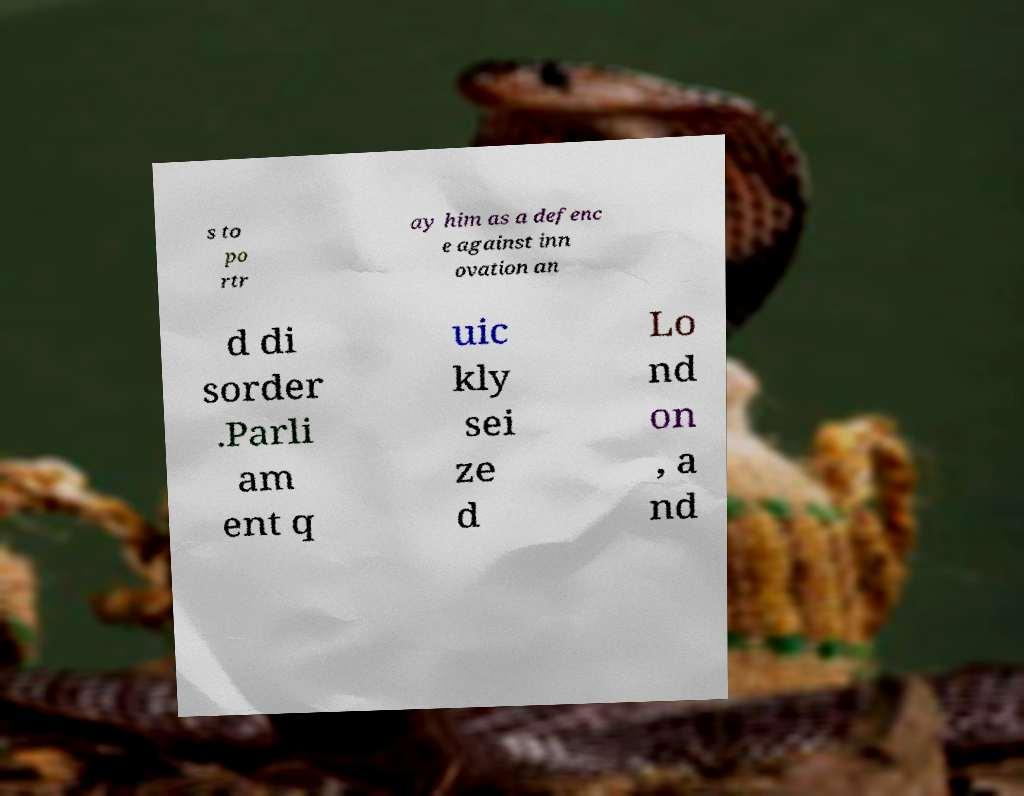There's text embedded in this image that I need extracted. Can you transcribe it verbatim? s to po rtr ay him as a defenc e against inn ovation an d di sorder .Parli am ent q uic kly sei ze d Lo nd on , a nd 